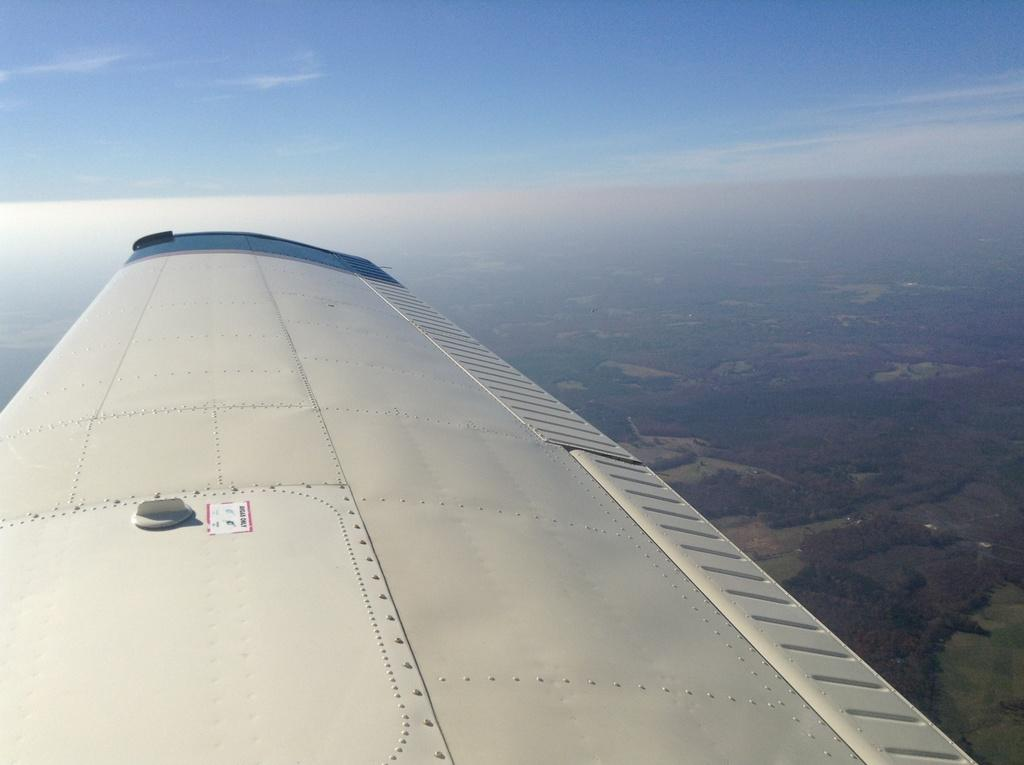What is the main subject of the image? The main subject of the image is a wing of an airplane in the sky. What can be seen in the background of the image? There is a group of trees in the background of the image. What type of farm can be seen in the image? There is no farm present in the image; it features a wing of an airplane in the sky and a group of trees in the background. 